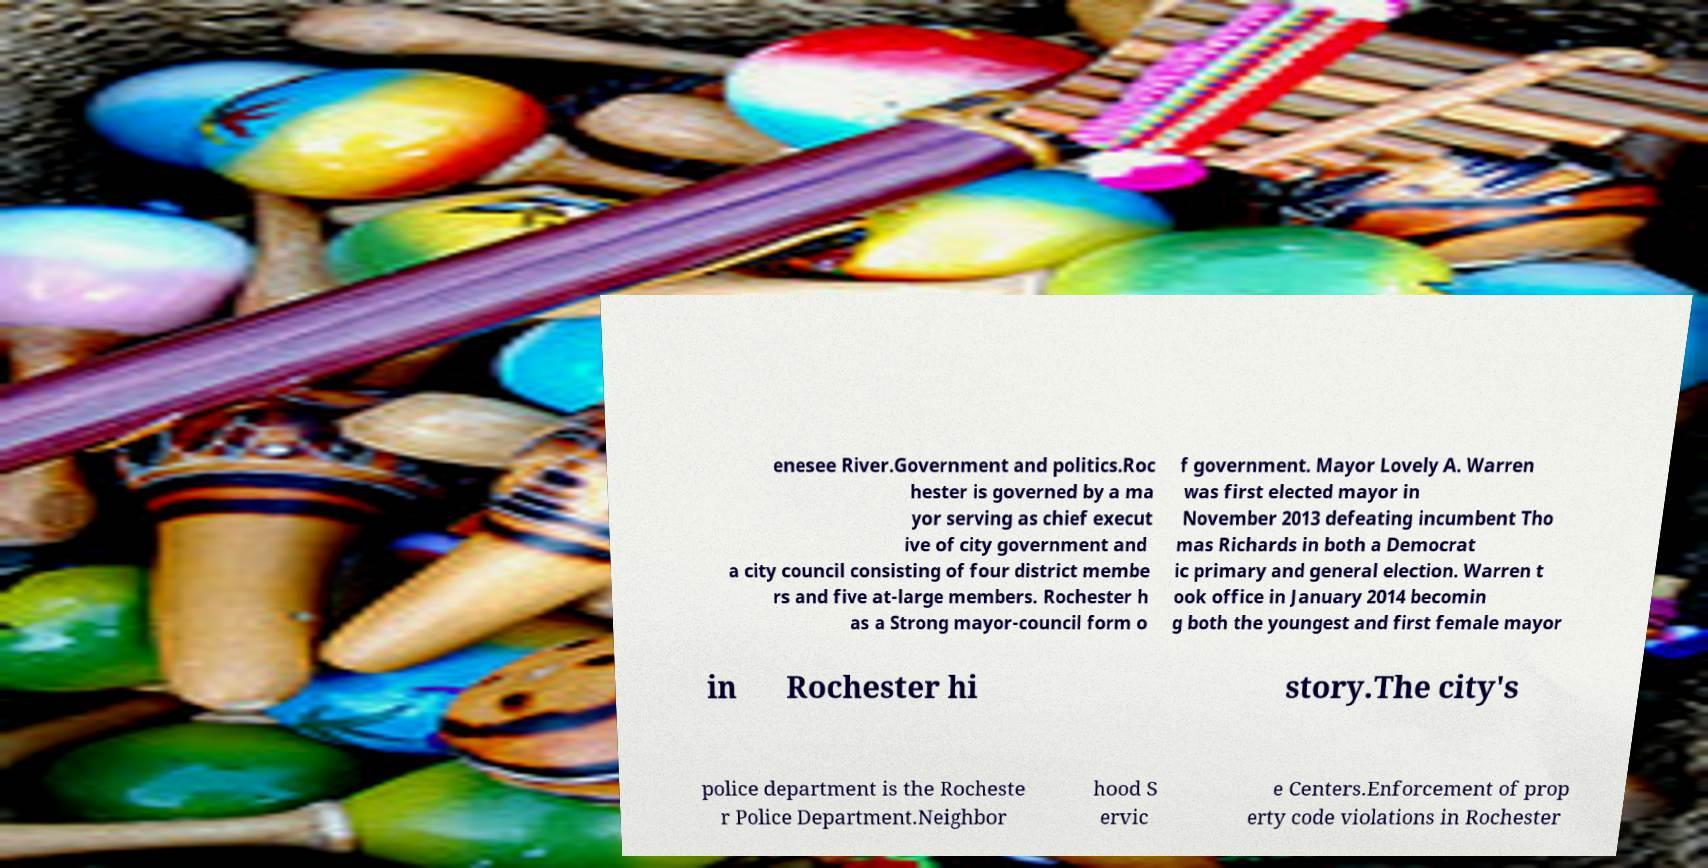I need the written content from this picture converted into text. Can you do that? enesee River.Government and politics.Roc hester is governed by a ma yor serving as chief execut ive of city government and a city council consisting of four district membe rs and five at-large members. Rochester h as a Strong mayor-council form o f government. Mayor Lovely A. Warren was first elected mayor in November 2013 defeating incumbent Tho mas Richards in both a Democrat ic primary and general election. Warren t ook office in January 2014 becomin g both the youngest and first female mayor in Rochester hi story.The city's police department is the Rocheste r Police Department.Neighbor hood S ervic e Centers.Enforcement of prop erty code violations in Rochester 